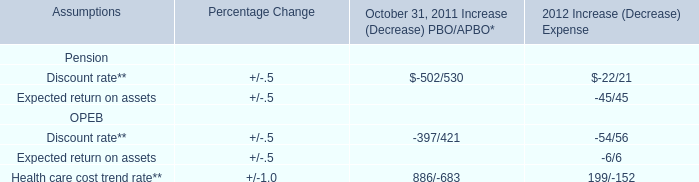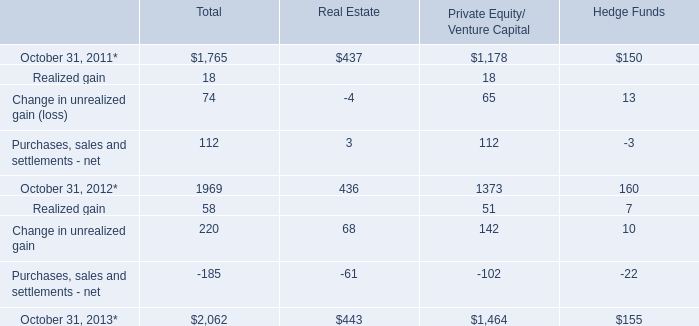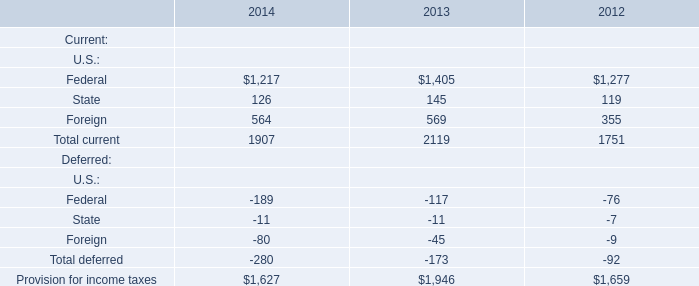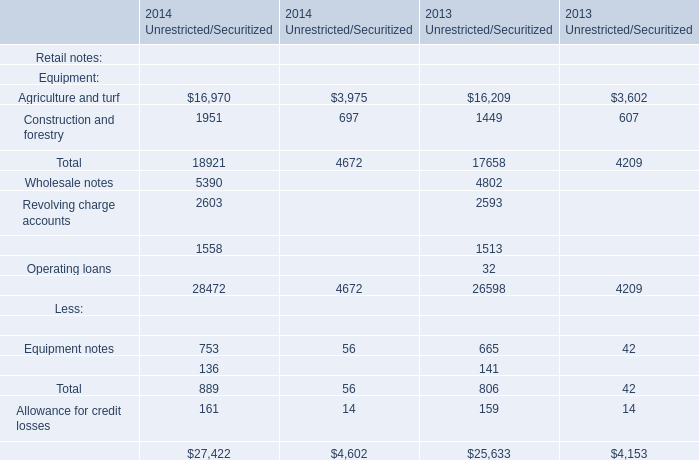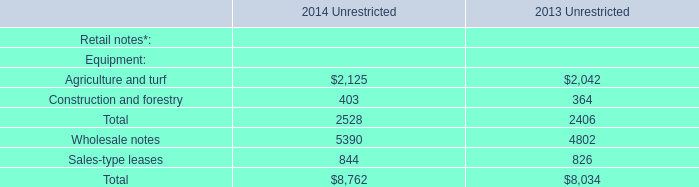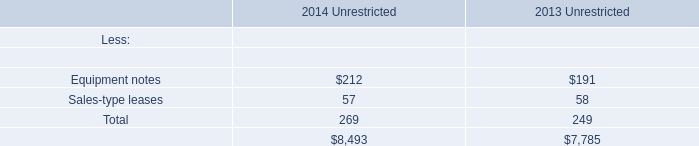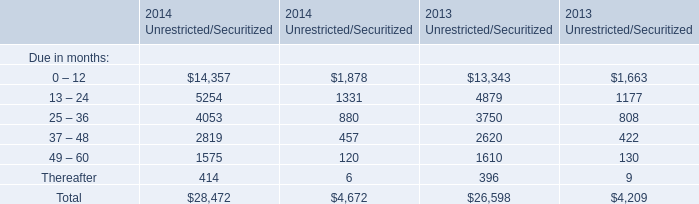What is the growing rate of Equipment notes in the year with the least Sales-type leases? 
Computations: ((212 - 191) / 191)
Answer: 0.10995. 